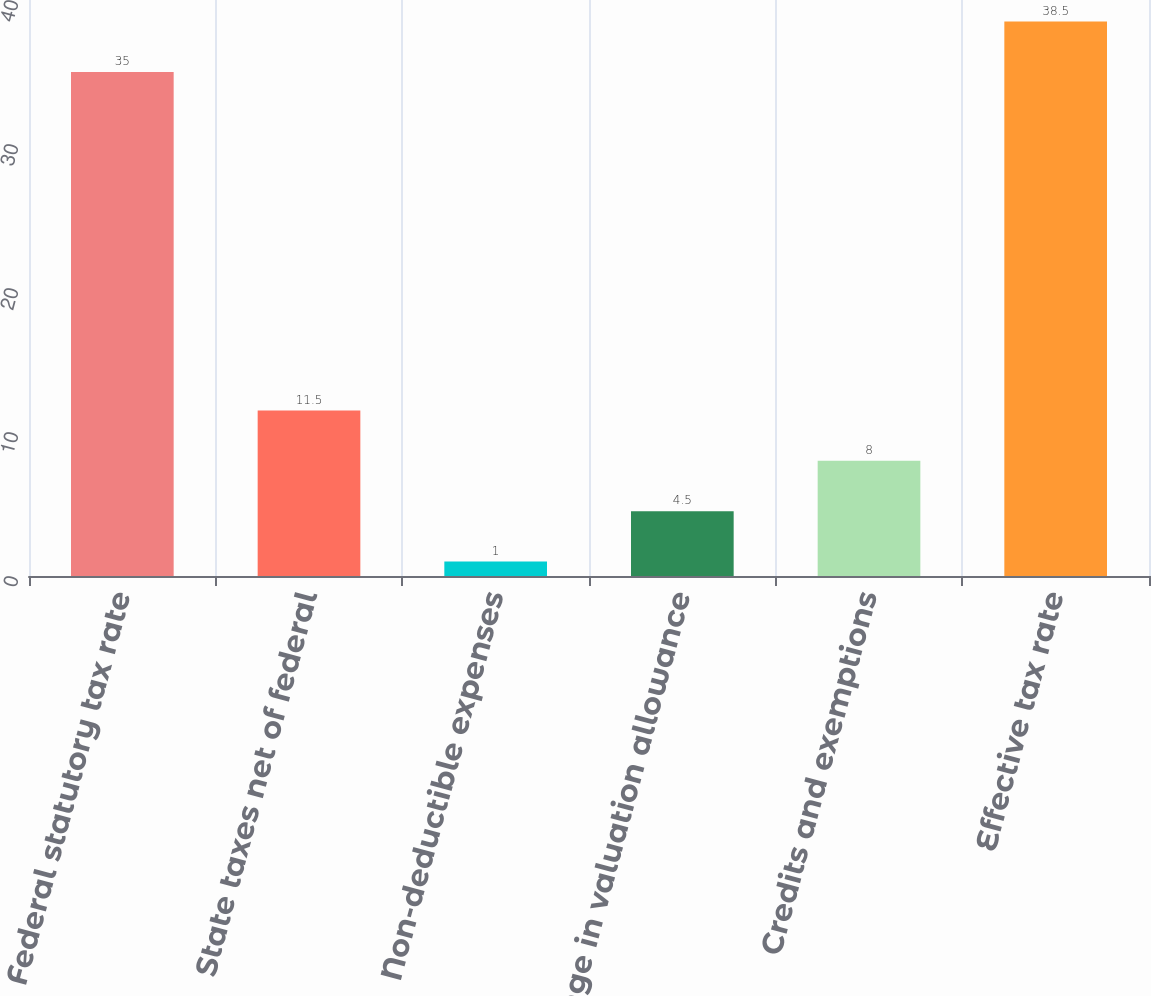Convert chart. <chart><loc_0><loc_0><loc_500><loc_500><bar_chart><fcel>Federal statutory tax rate<fcel>State taxes net of federal<fcel>Non-deductible expenses<fcel>Change in valuation allowance<fcel>Credits and exemptions<fcel>Effective tax rate<nl><fcel>35<fcel>11.5<fcel>1<fcel>4.5<fcel>8<fcel>38.5<nl></chart> 